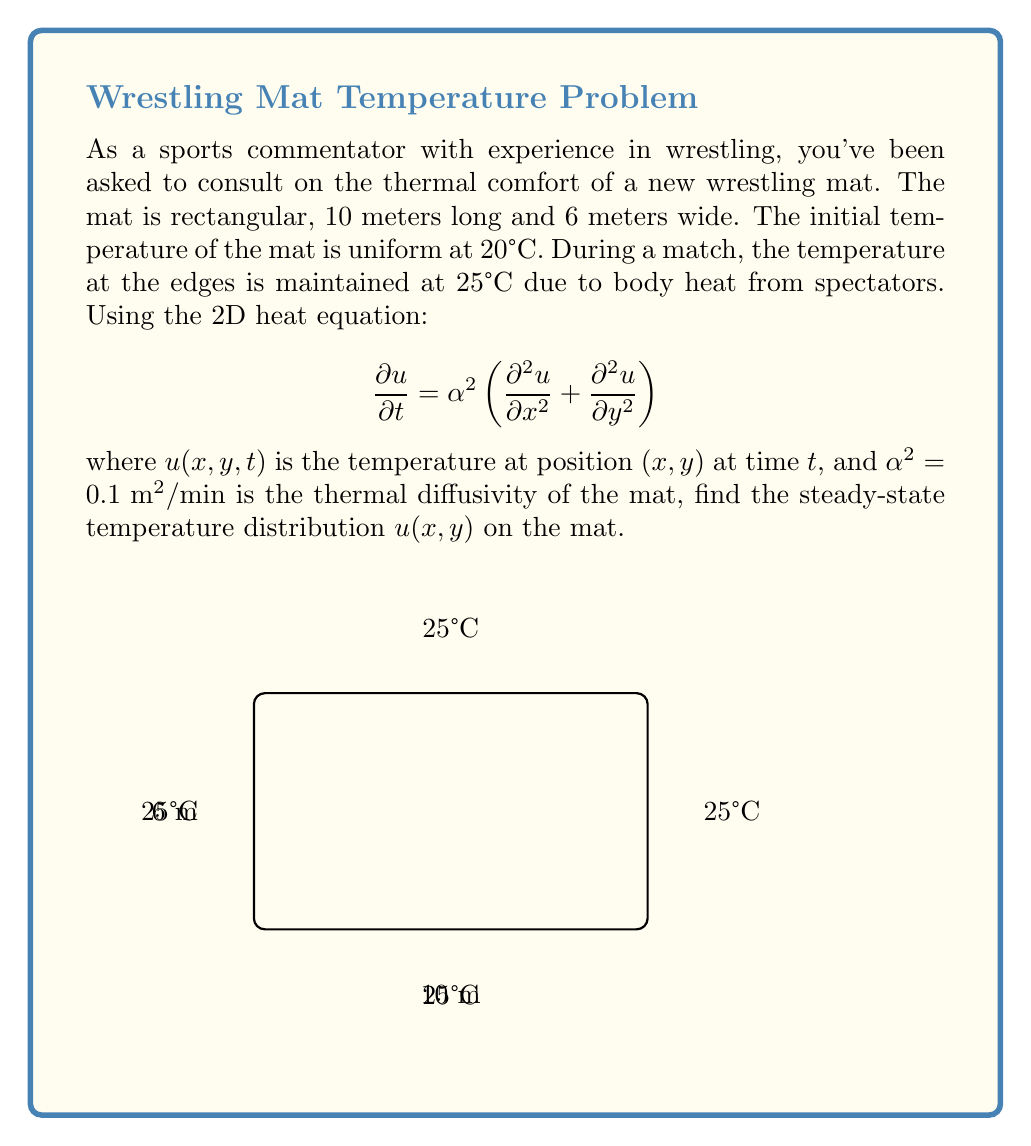What is the answer to this math problem? To solve this problem, we'll follow these steps:

1) For the steady-state solution, the temperature doesn't change with time, so $\frac{\partial u}{\partial t} = 0$. The heat equation reduces to Laplace's equation:

   $$\frac{\partial^2 u}{\partial x^2} + \frac{\partial^2 u}{\partial y^2} = 0$$

2) The boundary conditions are:
   $u(0,y) = u(10,y) = u(x,0) = u(x,6) = 25$ for $0 \leq x \leq 10$ and $0 \leq y \leq 6$

3) We can solve this using separation of variables. Let $u(x,y) = X(x)Y(y)$. Substituting into Laplace's equation:

   $$X''Y + XY'' = 0$$
   $$\frac{X''}{X} = -\frac{Y''}{Y} = -\lambda^2$$

4) This gives us two ODEs:
   $X'' + \lambda^2 X = 0$ and $Y'' + \lambda^2 Y = 0$

5) The general solutions are:
   $X(x) = A \cos(\lambda x) + B \sin(\lambda x)$
   $Y(y) = C \cos(\lambda y) + D \sin(\lambda y)$

6) Applying the boundary conditions:
   $X(0) = X(10) = 25$ gives $\lambda_n = \frac{n\pi}{10}$ for $n = 1,2,3,...$
   $Y(0) = Y(6) = 25$ gives $\lambda_m = \frac{m\pi}{6}$ for $m = 1,2,3,...$

7) The complete solution is a double Fourier series:

   $$u(x,y) = 25 + \sum_{n=1}^{\infty}\sum_{m=1}^{\infty} A_{nm} \sin(\frac{n\pi x}{10}) \sin(\frac{m\pi y}{6})$$

8) The coefficients $A_{nm}$ can be determined using the initial condition, but for the steady-state solution, we only need the constant term 25°C.

Therefore, the steady-state temperature distribution is uniform at 25°C across the entire mat.
Answer: $u(x,y) = 25°C$ 